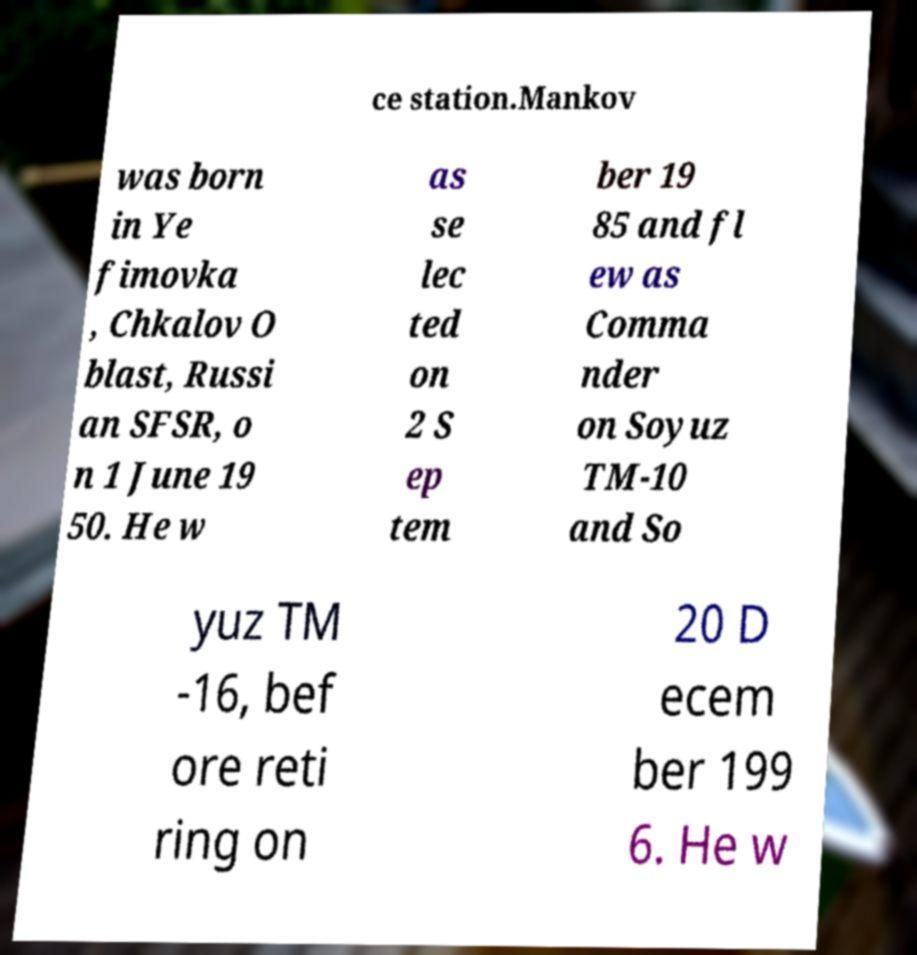For documentation purposes, I need the text within this image transcribed. Could you provide that? ce station.Mankov was born in Ye fimovka , Chkalov O blast, Russi an SFSR, o n 1 June 19 50. He w as se lec ted on 2 S ep tem ber 19 85 and fl ew as Comma nder on Soyuz TM-10 and So yuz TM -16, bef ore reti ring on 20 D ecem ber 199 6. He w 